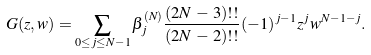<formula> <loc_0><loc_0><loc_500><loc_500>\ G ( z , w ) = \sum _ { 0 \leq j \leq N - 1 } \beta _ { j } ^ { ( N ) } \frac { ( 2 N \, - \, 3 ) ! ! } { ( 2 N \, - \, 2 ) ! ! } ( - 1 ) ^ { j - 1 } z ^ { j } w ^ { N - 1 - j } .</formula> 